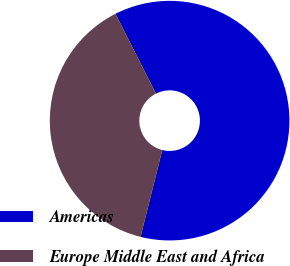Convert chart. <chart><loc_0><loc_0><loc_500><loc_500><pie_chart><fcel>Americas<fcel>Europe Middle East and Africa<nl><fcel>61.38%<fcel>38.62%<nl></chart> 